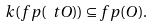<formula> <loc_0><loc_0><loc_500><loc_500>k ( f p ( \ t O ) ) \subseteq f p ( O ) .</formula> 